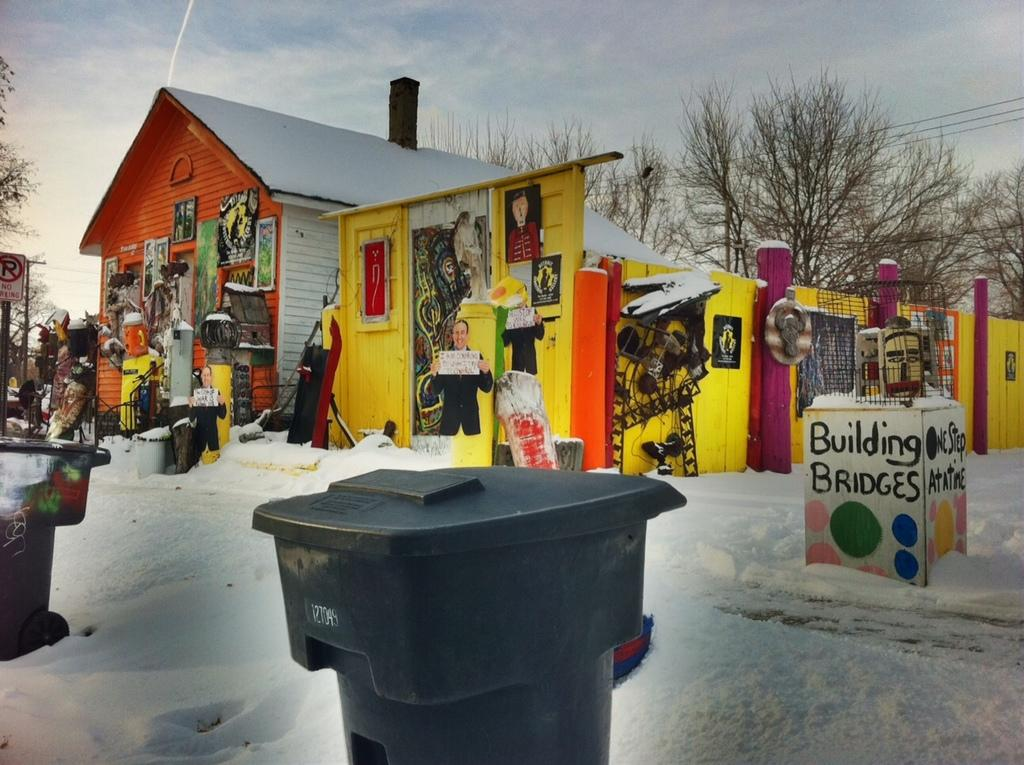Provide a one-sentence caption for the provided image. Next to a very bright orange and yellow building is a small, square structure that says building bridges. 